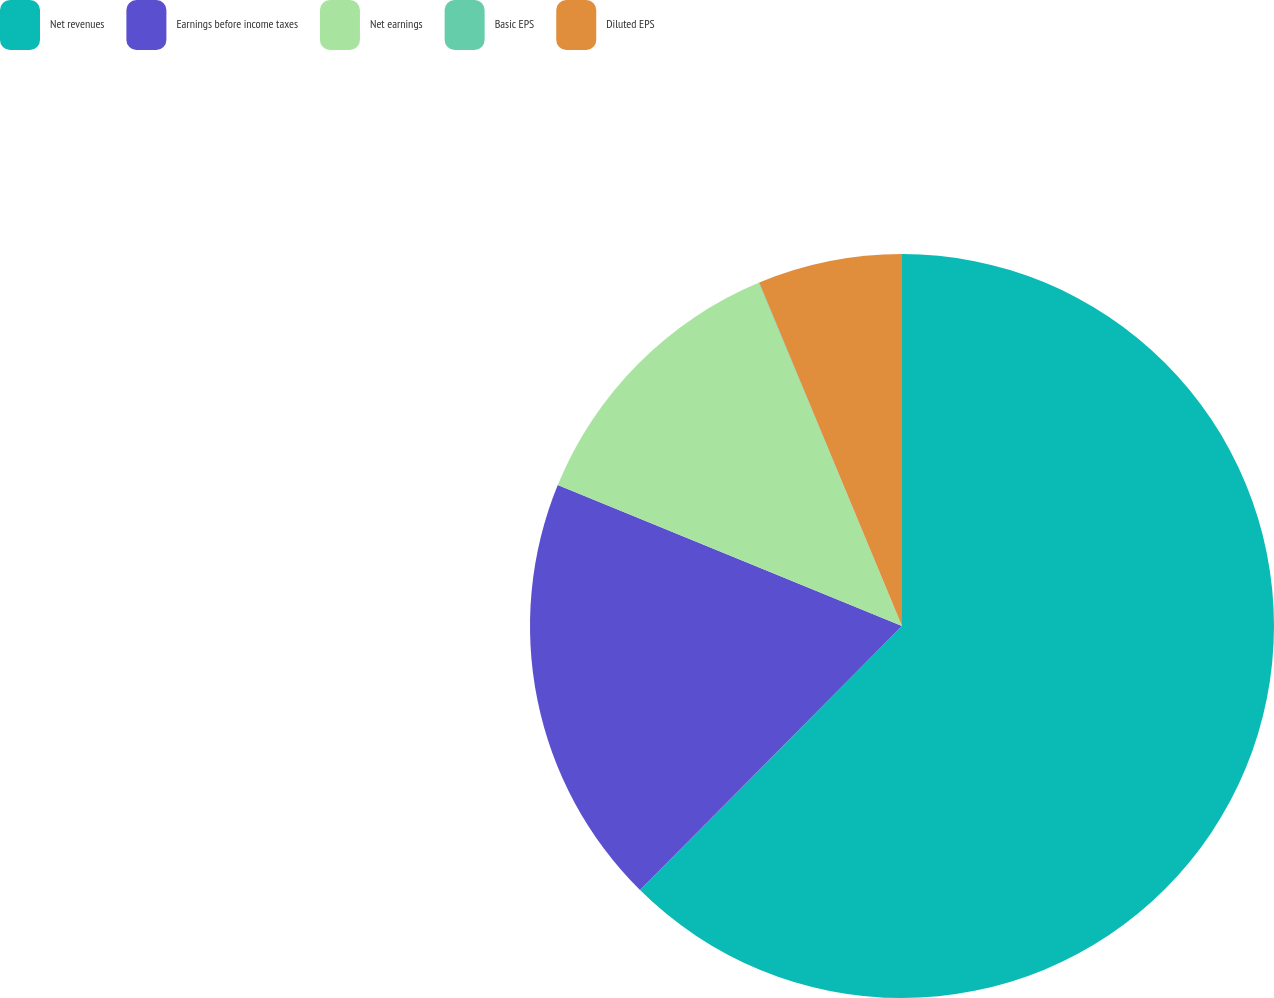<chart> <loc_0><loc_0><loc_500><loc_500><pie_chart><fcel>Net revenues<fcel>Earnings before income taxes<fcel>Net earnings<fcel>Basic EPS<fcel>Diluted EPS<nl><fcel>62.43%<fcel>18.75%<fcel>12.51%<fcel>0.03%<fcel>6.27%<nl></chart> 